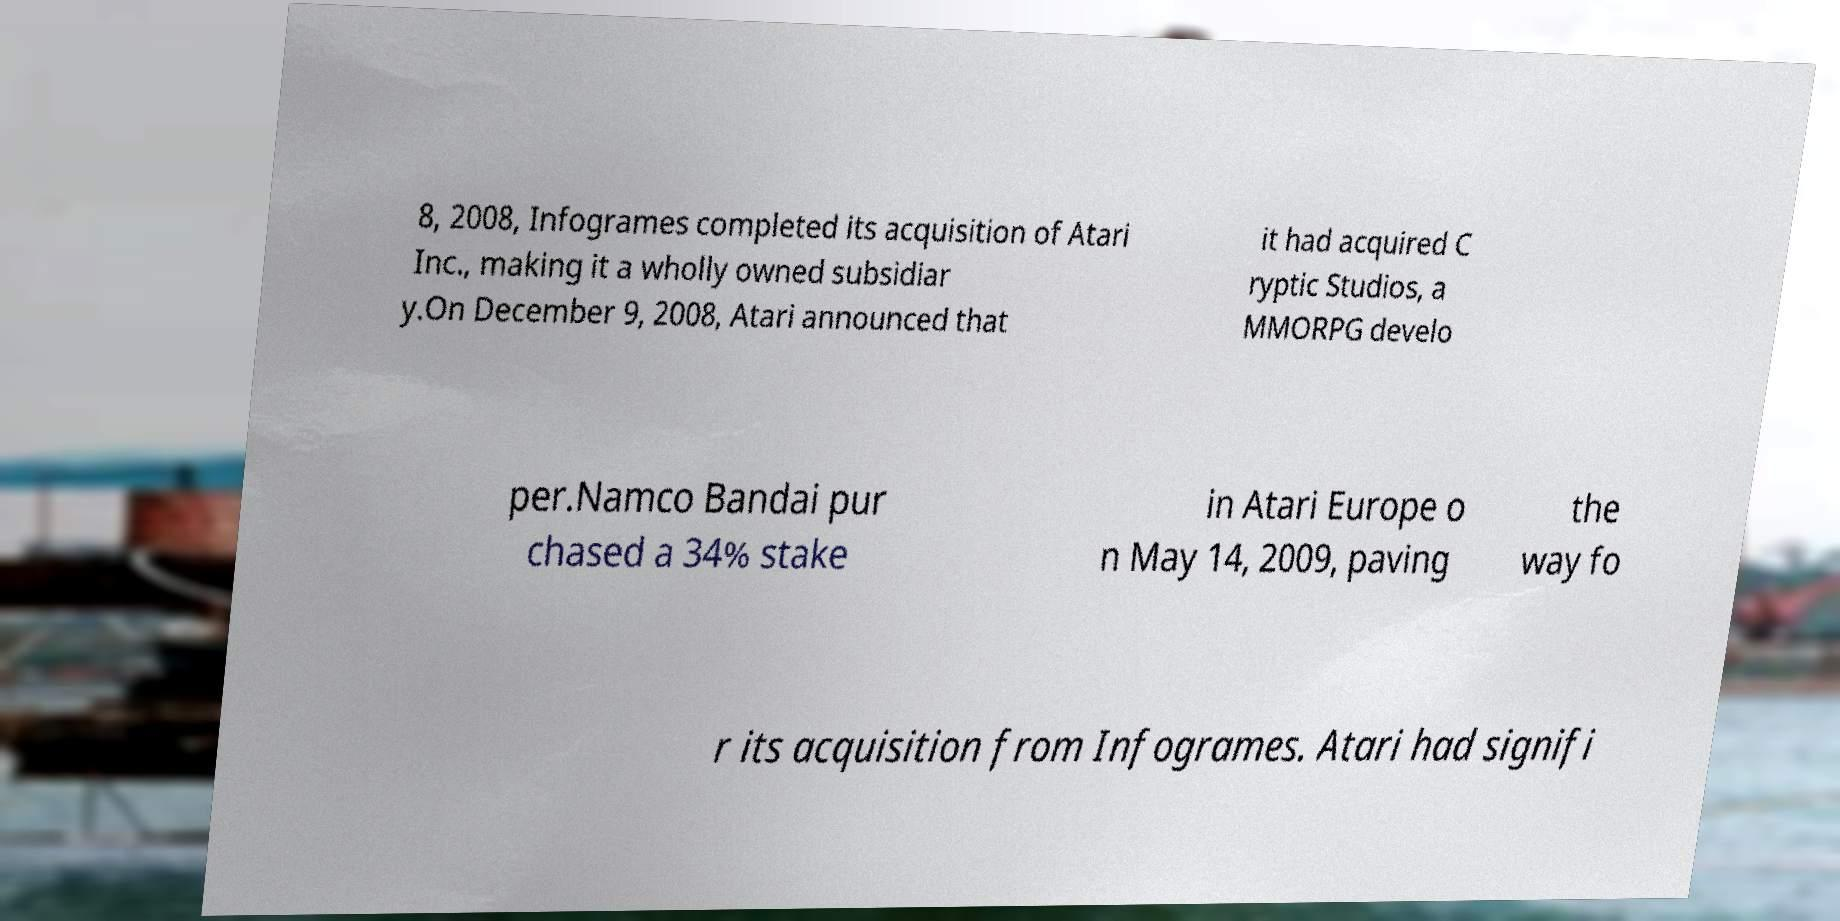Can you accurately transcribe the text from the provided image for me? 8, 2008, Infogrames completed its acquisition of Atari Inc., making it a wholly owned subsidiar y.On December 9, 2008, Atari announced that it had acquired C ryptic Studios, a MMORPG develo per.Namco Bandai pur chased a 34% stake in Atari Europe o n May 14, 2009, paving the way fo r its acquisition from Infogrames. Atari had signifi 